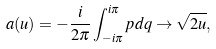<formula> <loc_0><loc_0><loc_500><loc_500>a ( u ) = - \frac { i } { 2 \pi } \int _ { - i \pi } ^ { i \pi } p d q \rightarrow \sqrt { 2 u } ,</formula> 